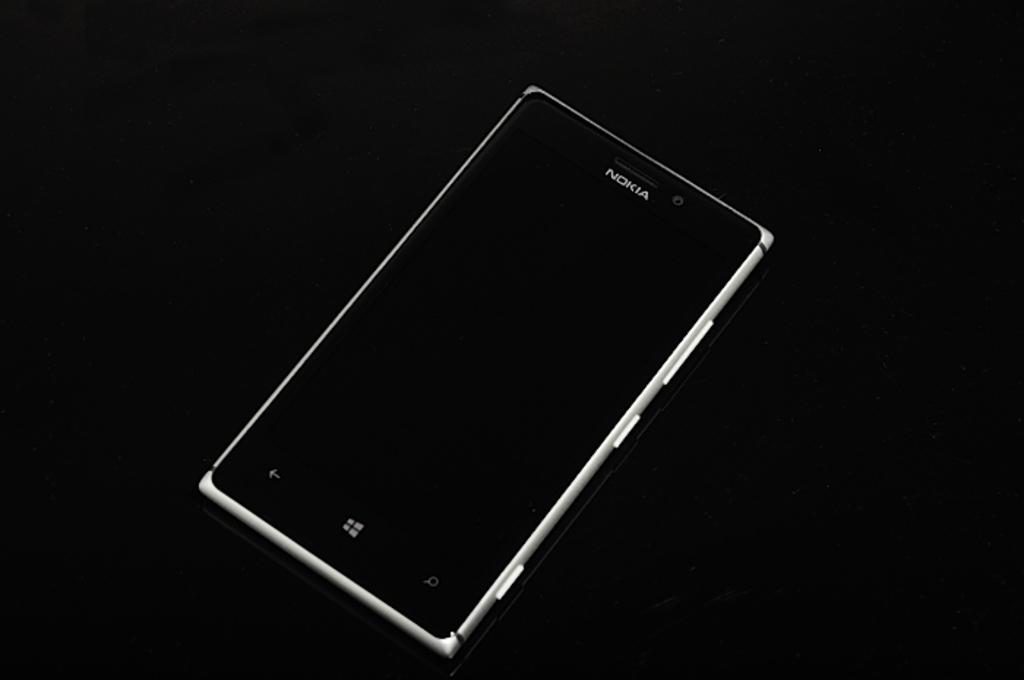What's the brand name on the phone?
Your answer should be compact. Nokia. 